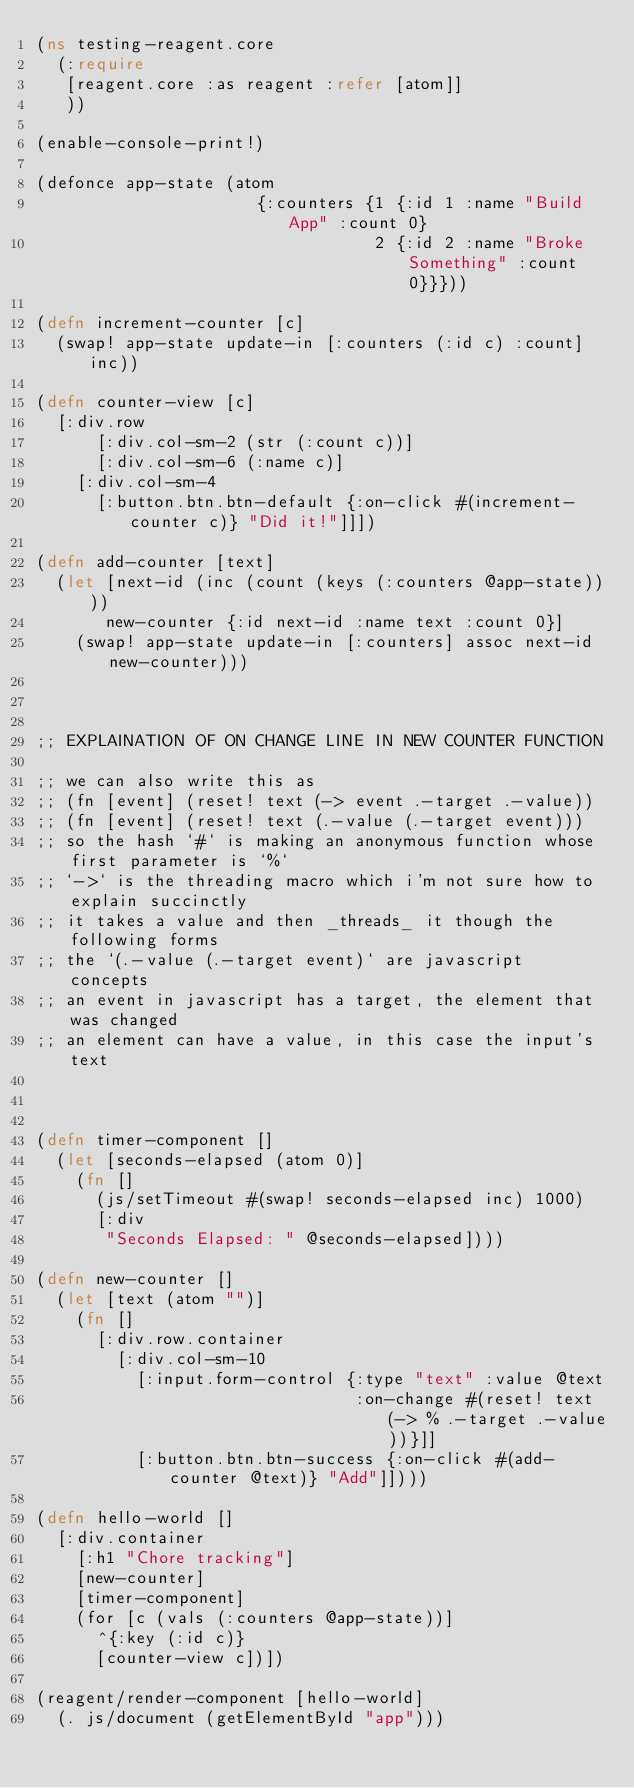Convert code to text. <code><loc_0><loc_0><loc_500><loc_500><_Clojure_>(ns testing-reagent.core
  (:require
   [reagent.core :as reagent :refer [atom]]
   ))

(enable-console-print!)

(defonce app-state (atom 
                      {:counters {1 {:id 1 :name "Build App" :count 0}
                                  2 {:id 2 :name "Broke Something" :count 0}}}))

(defn increment-counter [c]
  (swap! app-state update-in [:counters (:id c) :count] inc))

(defn counter-view [c]
  [:div.row
      [:div.col-sm-2 (str (:count c))]
      [:div.col-sm-6 (:name c)]
    [:div.col-sm-4
      [:button.btn.btn-default {:on-click #(increment-counter c)} "Did it!"]]])

(defn add-counter [text]
  (let [next-id (inc (count (keys (:counters @app-state))))
       new-counter {:id next-id :name text :count 0}]
    (swap! app-state update-in [:counters] assoc next-id new-counter)))



;; EXPLAINATION OF ON CHANGE LINE IN NEW COUNTER FUNCTION 

;; we can also write this as
;; (fn [event] (reset! text (-> event .-target .-value))
;; (fn [event] (reset! text (.-value (.-target event)))
;; so the hash `#` is making an anonymous function whose first parameter is `%`
;; `->` is the threading macro which i'm not sure how to explain succinctly
;; it takes a value and then _threads_ it though the following forms
;; the `(.-value (.-target event)` are javascript concepts
;; an event in javascript has a target, the element that was changed
;; an element can have a value, in this case the input's text



(defn timer-component []
  (let [seconds-elapsed (atom 0)]
    (fn []
      (js/setTimeout #(swap! seconds-elapsed inc) 1000)
      [:div
       "Seconds Elapsed: " @seconds-elapsed])))

(defn new-counter []
  (let [text (atom "")]
    (fn []
      [:div.row.container
        [:div.col-sm-10
          [:input.form-control {:type "text" :value @text
                                :on-change #(reset! text (-> % .-target .-value))}]]
          [:button.btn.btn-success {:on-click #(add-counter @text)} "Add"]])))

(defn hello-world []
  [:div.container
    [:h1 "Chore tracking"]
    [new-counter]
    [timer-component]
    (for [c (vals (:counters @app-state))]
      ^{:key (:id c)}
      [counter-view c])])

(reagent/render-component [hello-world]
  (. js/document (getElementById "app")))</code> 